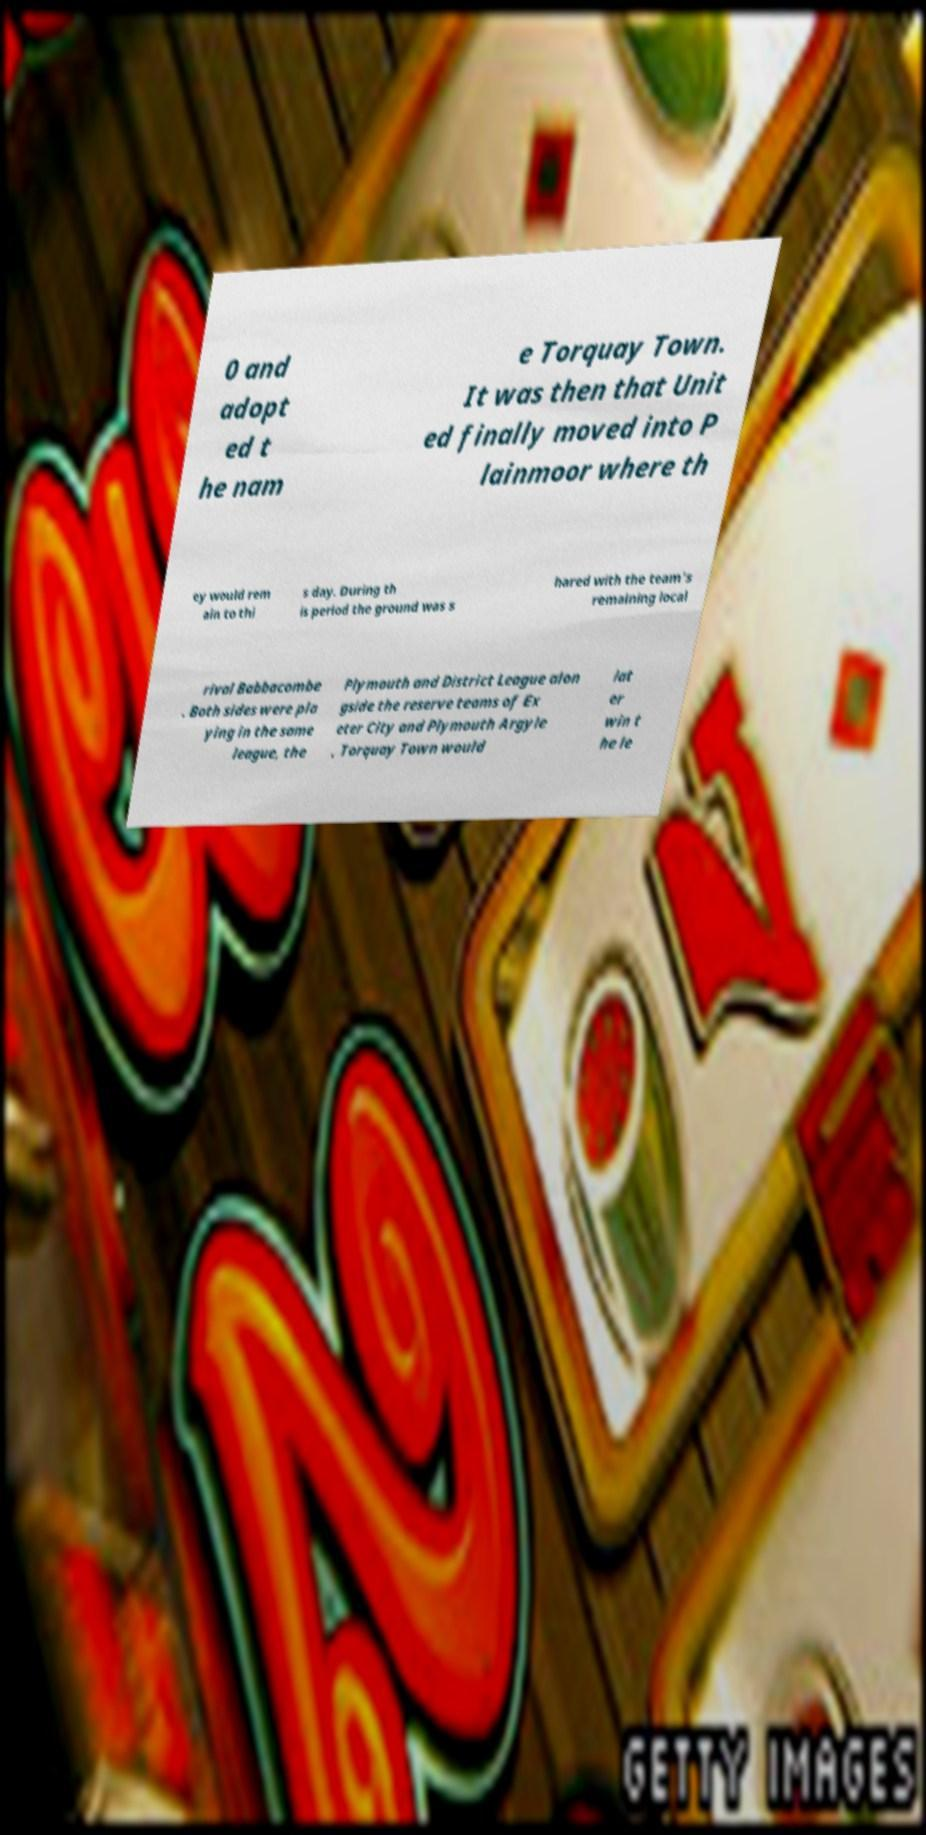Could you extract and type out the text from this image? 0 and adopt ed t he nam e Torquay Town. It was then that Unit ed finally moved into P lainmoor where th ey would rem ain to thi s day. During th is period the ground was s hared with the team's remaining local rival Babbacombe . Both sides were pla ying in the same league, the Plymouth and District League alon gside the reserve teams of Ex eter City and Plymouth Argyle , Torquay Town would lat er win t he le 